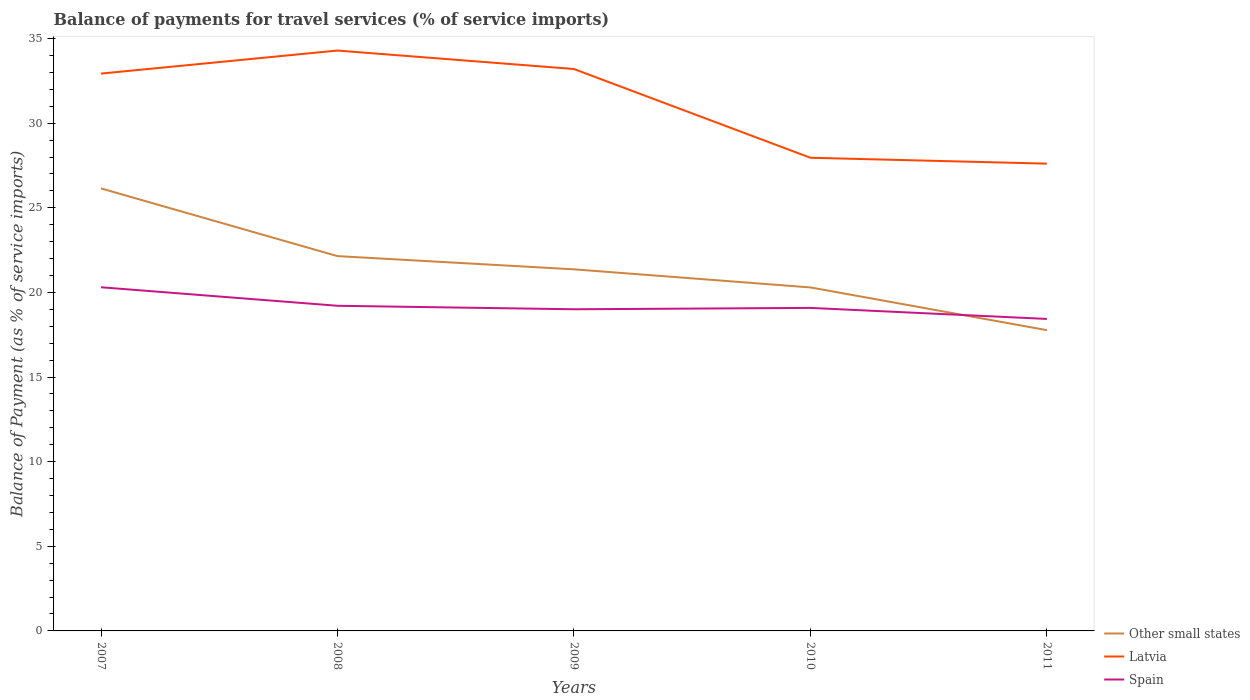Does the line corresponding to Latvia intersect with the line corresponding to Other small states?
Provide a short and direct response. No. Across all years, what is the maximum balance of payments for travel services in Latvia?
Keep it short and to the point. 27.61. What is the total balance of payments for travel services in Spain in the graph?
Your response must be concise. 0.21. What is the difference between the highest and the second highest balance of payments for travel services in Spain?
Give a very brief answer. 1.87. How many lines are there?
Give a very brief answer. 3. How many years are there in the graph?
Provide a short and direct response. 5. What is the difference between two consecutive major ticks on the Y-axis?
Keep it short and to the point. 5. Does the graph contain grids?
Your response must be concise. No. Where does the legend appear in the graph?
Your answer should be very brief. Bottom right. How many legend labels are there?
Offer a terse response. 3. What is the title of the graph?
Give a very brief answer. Balance of payments for travel services (% of service imports). Does "Czech Republic" appear as one of the legend labels in the graph?
Provide a succinct answer. No. What is the label or title of the Y-axis?
Provide a succinct answer. Balance of Payment (as % of service imports). What is the Balance of Payment (as % of service imports) in Other small states in 2007?
Ensure brevity in your answer.  26.15. What is the Balance of Payment (as % of service imports) in Latvia in 2007?
Ensure brevity in your answer.  32.93. What is the Balance of Payment (as % of service imports) of Spain in 2007?
Provide a succinct answer. 20.31. What is the Balance of Payment (as % of service imports) in Other small states in 2008?
Your answer should be compact. 22.15. What is the Balance of Payment (as % of service imports) in Latvia in 2008?
Provide a succinct answer. 34.29. What is the Balance of Payment (as % of service imports) of Spain in 2008?
Offer a very short reply. 19.21. What is the Balance of Payment (as % of service imports) in Other small states in 2009?
Your answer should be compact. 21.37. What is the Balance of Payment (as % of service imports) of Latvia in 2009?
Your answer should be compact. 33.2. What is the Balance of Payment (as % of service imports) of Spain in 2009?
Offer a very short reply. 19.01. What is the Balance of Payment (as % of service imports) of Other small states in 2010?
Your answer should be compact. 20.3. What is the Balance of Payment (as % of service imports) of Latvia in 2010?
Offer a very short reply. 27.96. What is the Balance of Payment (as % of service imports) in Spain in 2010?
Give a very brief answer. 19.09. What is the Balance of Payment (as % of service imports) in Other small states in 2011?
Provide a succinct answer. 17.77. What is the Balance of Payment (as % of service imports) of Latvia in 2011?
Provide a succinct answer. 27.61. What is the Balance of Payment (as % of service imports) of Spain in 2011?
Offer a very short reply. 18.44. Across all years, what is the maximum Balance of Payment (as % of service imports) of Other small states?
Offer a very short reply. 26.15. Across all years, what is the maximum Balance of Payment (as % of service imports) in Latvia?
Your answer should be compact. 34.29. Across all years, what is the maximum Balance of Payment (as % of service imports) in Spain?
Provide a short and direct response. 20.31. Across all years, what is the minimum Balance of Payment (as % of service imports) in Other small states?
Your answer should be very brief. 17.77. Across all years, what is the minimum Balance of Payment (as % of service imports) in Latvia?
Provide a short and direct response. 27.61. Across all years, what is the minimum Balance of Payment (as % of service imports) of Spain?
Your answer should be compact. 18.44. What is the total Balance of Payment (as % of service imports) of Other small states in the graph?
Offer a very short reply. 107.73. What is the total Balance of Payment (as % of service imports) of Latvia in the graph?
Give a very brief answer. 156. What is the total Balance of Payment (as % of service imports) of Spain in the graph?
Your response must be concise. 96.05. What is the difference between the Balance of Payment (as % of service imports) of Other small states in 2007 and that in 2008?
Ensure brevity in your answer.  4. What is the difference between the Balance of Payment (as % of service imports) in Latvia in 2007 and that in 2008?
Offer a terse response. -1.36. What is the difference between the Balance of Payment (as % of service imports) in Spain in 2007 and that in 2008?
Offer a very short reply. 1.09. What is the difference between the Balance of Payment (as % of service imports) in Other small states in 2007 and that in 2009?
Offer a very short reply. 4.78. What is the difference between the Balance of Payment (as % of service imports) of Latvia in 2007 and that in 2009?
Provide a succinct answer. -0.27. What is the difference between the Balance of Payment (as % of service imports) of Spain in 2007 and that in 2009?
Keep it short and to the point. 1.3. What is the difference between the Balance of Payment (as % of service imports) in Other small states in 2007 and that in 2010?
Offer a very short reply. 5.85. What is the difference between the Balance of Payment (as % of service imports) in Latvia in 2007 and that in 2010?
Your answer should be very brief. 4.97. What is the difference between the Balance of Payment (as % of service imports) in Spain in 2007 and that in 2010?
Provide a short and direct response. 1.22. What is the difference between the Balance of Payment (as % of service imports) of Other small states in 2007 and that in 2011?
Your answer should be compact. 8.38. What is the difference between the Balance of Payment (as % of service imports) in Latvia in 2007 and that in 2011?
Provide a short and direct response. 5.32. What is the difference between the Balance of Payment (as % of service imports) of Spain in 2007 and that in 2011?
Offer a very short reply. 1.87. What is the difference between the Balance of Payment (as % of service imports) in Other small states in 2008 and that in 2009?
Give a very brief answer. 0.78. What is the difference between the Balance of Payment (as % of service imports) in Latvia in 2008 and that in 2009?
Give a very brief answer. 1.09. What is the difference between the Balance of Payment (as % of service imports) in Spain in 2008 and that in 2009?
Your answer should be compact. 0.21. What is the difference between the Balance of Payment (as % of service imports) in Other small states in 2008 and that in 2010?
Offer a terse response. 1.85. What is the difference between the Balance of Payment (as % of service imports) of Latvia in 2008 and that in 2010?
Offer a terse response. 6.33. What is the difference between the Balance of Payment (as % of service imports) of Spain in 2008 and that in 2010?
Provide a succinct answer. 0.13. What is the difference between the Balance of Payment (as % of service imports) in Other small states in 2008 and that in 2011?
Your answer should be compact. 4.38. What is the difference between the Balance of Payment (as % of service imports) in Latvia in 2008 and that in 2011?
Ensure brevity in your answer.  6.68. What is the difference between the Balance of Payment (as % of service imports) in Spain in 2008 and that in 2011?
Provide a succinct answer. 0.78. What is the difference between the Balance of Payment (as % of service imports) of Other small states in 2009 and that in 2010?
Ensure brevity in your answer.  1.07. What is the difference between the Balance of Payment (as % of service imports) in Latvia in 2009 and that in 2010?
Give a very brief answer. 5.24. What is the difference between the Balance of Payment (as % of service imports) of Spain in 2009 and that in 2010?
Ensure brevity in your answer.  -0.08. What is the difference between the Balance of Payment (as % of service imports) of Other small states in 2009 and that in 2011?
Your answer should be very brief. 3.59. What is the difference between the Balance of Payment (as % of service imports) in Latvia in 2009 and that in 2011?
Keep it short and to the point. 5.59. What is the difference between the Balance of Payment (as % of service imports) in Spain in 2009 and that in 2011?
Ensure brevity in your answer.  0.57. What is the difference between the Balance of Payment (as % of service imports) of Other small states in 2010 and that in 2011?
Ensure brevity in your answer.  2.53. What is the difference between the Balance of Payment (as % of service imports) of Latvia in 2010 and that in 2011?
Give a very brief answer. 0.35. What is the difference between the Balance of Payment (as % of service imports) of Spain in 2010 and that in 2011?
Keep it short and to the point. 0.65. What is the difference between the Balance of Payment (as % of service imports) of Other small states in 2007 and the Balance of Payment (as % of service imports) of Latvia in 2008?
Your answer should be compact. -8.14. What is the difference between the Balance of Payment (as % of service imports) of Other small states in 2007 and the Balance of Payment (as % of service imports) of Spain in 2008?
Give a very brief answer. 6.94. What is the difference between the Balance of Payment (as % of service imports) of Latvia in 2007 and the Balance of Payment (as % of service imports) of Spain in 2008?
Your answer should be compact. 13.72. What is the difference between the Balance of Payment (as % of service imports) in Other small states in 2007 and the Balance of Payment (as % of service imports) in Latvia in 2009?
Your response must be concise. -7.06. What is the difference between the Balance of Payment (as % of service imports) in Other small states in 2007 and the Balance of Payment (as % of service imports) in Spain in 2009?
Your answer should be very brief. 7.14. What is the difference between the Balance of Payment (as % of service imports) of Latvia in 2007 and the Balance of Payment (as % of service imports) of Spain in 2009?
Provide a short and direct response. 13.93. What is the difference between the Balance of Payment (as % of service imports) of Other small states in 2007 and the Balance of Payment (as % of service imports) of Latvia in 2010?
Ensure brevity in your answer.  -1.81. What is the difference between the Balance of Payment (as % of service imports) in Other small states in 2007 and the Balance of Payment (as % of service imports) in Spain in 2010?
Make the answer very short. 7.06. What is the difference between the Balance of Payment (as % of service imports) in Latvia in 2007 and the Balance of Payment (as % of service imports) in Spain in 2010?
Keep it short and to the point. 13.84. What is the difference between the Balance of Payment (as % of service imports) in Other small states in 2007 and the Balance of Payment (as % of service imports) in Latvia in 2011?
Give a very brief answer. -1.46. What is the difference between the Balance of Payment (as % of service imports) in Other small states in 2007 and the Balance of Payment (as % of service imports) in Spain in 2011?
Keep it short and to the point. 7.71. What is the difference between the Balance of Payment (as % of service imports) in Latvia in 2007 and the Balance of Payment (as % of service imports) in Spain in 2011?
Keep it short and to the point. 14.5. What is the difference between the Balance of Payment (as % of service imports) in Other small states in 2008 and the Balance of Payment (as % of service imports) in Latvia in 2009?
Ensure brevity in your answer.  -11.06. What is the difference between the Balance of Payment (as % of service imports) in Other small states in 2008 and the Balance of Payment (as % of service imports) in Spain in 2009?
Offer a terse response. 3.14. What is the difference between the Balance of Payment (as % of service imports) of Latvia in 2008 and the Balance of Payment (as % of service imports) of Spain in 2009?
Your response must be concise. 15.29. What is the difference between the Balance of Payment (as % of service imports) of Other small states in 2008 and the Balance of Payment (as % of service imports) of Latvia in 2010?
Offer a very short reply. -5.81. What is the difference between the Balance of Payment (as % of service imports) in Other small states in 2008 and the Balance of Payment (as % of service imports) in Spain in 2010?
Your answer should be compact. 3.06. What is the difference between the Balance of Payment (as % of service imports) of Latvia in 2008 and the Balance of Payment (as % of service imports) of Spain in 2010?
Give a very brief answer. 15.21. What is the difference between the Balance of Payment (as % of service imports) in Other small states in 2008 and the Balance of Payment (as % of service imports) in Latvia in 2011?
Offer a very short reply. -5.46. What is the difference between the Balance of Payment (as % of service imports) in Other small states in 2008 and the Balance of Payment (as % of service imports) in Spain in 2011?
Your answer should be very brief. 3.71. What is the difference between the Balance of Payment (as % of service imports) in Latvia in 2008 and the Balance of Payment (as % of service imports) in Spain in 2011?
Provide a succinct answer. 15.86. What is the difference between the Balance of Payment (as % of service imports) of Other small states in 2009 and the Balance of Payment (as % of service imports) of Latvia in 2010?
Your answer should be very brief. -6.59. What is the difference between the Balance of Payment (as % of service imports) in Other small states in 2009 and the Balance of Payment (as % of service imports) in Spain in 2010?
Make the answer very short. 2.28. What is the difference between the Balance of Payment (as % of service imports) of Latvia in 2009 and the Balance of Payment (as % of service imports) of Spain in 2010?
Your response must be concise. 14.12. What is the difference between the Balance of Payment (as % of service imports) of Other small states in 2009 and the Balance of Payment (as % of service imports) of Latvia in 2011?
Your response must be concise. -6.25. What is the difference between the Balance of Payment (as % of service imports) of Other small states in 2009 and the Balance of Payment (as % of service imports) of Spain in 2011?
Offer a terse response. 2.93. What is the difference between the Balance of Payment (as % of service imports) in Latvia in 2009 and the Balance of Payment (as % of service imports) in Spain in 2011?
Provide a short and direct response. 14.77. What is the difference between the Balance of Payment (as % of service imports) in Other small states in 2010 and the Balance of Payment (as % of service imports) in Latvia in 2011?
Offer a very short reply. -7.31. What is the difference between the Balance of Payment (as % of service imports) of Other small states in 2010 and the Balance of Payment (as % of service imports) of Spain in 2011?
Your response must be concise. 1.86. What is the difference between the Balance of Payment (as % of service imports) in Latvia in 2010 and the Balance of Payment (as % of service imports) in Spain in 2011?
Your response must be concise. 9.52. What is the average Balance of Payment (as % of service imports) in Other small states per year?
Offer a terse response. 21.55. What is the average Balance of Payment (as % of service imports) in Latvia per year?
Offer a terse response. 31.2. What is the average Balance of Payment (as % of service imports) of Spain per year?
Offer a terse response. 19.21. In the year 2007, what is the difference between the Balance of Payment (as % of service imports) in Other small states and Balance of Payment (as % of service imports) in Latvia?
Your answer should be very brief. -6.78. In the year 2007, what is the difference between the Balance of Payment (as % of service imports) of Other small states and Balance of Payment (as % of service imports) of Spain?
Offer a very short reply. 5.84. In the year 2007, what is the difference between the Balance of Payment (as % of service imports) in Latvia and Balance of Payment (as % of service imports) in Spain?
Keep it short and to the point. 12.62. In the year 2008, what is the difference between the Balance of Payment (as % of service imports) in Other small states and Balance of Payment (as % of service imports) in Latvia?
Your answer should be very brief. -12.15. In the year 2008, what is the difference between the Balance of Payment (as % of service imports) in Other small states and Balance of Payment (as % of service imports) in Spain?
Ensure brevity in your answer.  2.93. In the year 2008, what is the difference between the Balance of Payment (as % of service imports) in Latvia and Balance of Payment (as % of service imports) in Spain?
Your answer should be compact. 15.08. In the year 2009, what is the difference between the Balance of Payment (as % of service imports) of Other small states and Balance of Payment (as % of service imports) of Latvia?
Your answer should be very brief. -11.84. In the year 2009, what is the difference between the Balance of Payment (as % of service imports) in Other small states and Balance of Payment (as % of service imports) in Spain?
Offer a very short reply. 2.36. In the year 2009, what is the difference between the Balance of Payment (as % of service imports) of Latvia and Balance of Payment (as % of service imports) of Spain?
Offer a terse response. 14.2. In the year 2010, what is the difference between the Balance of Payment (as % of service imports) in Other small states and Balance of Payment (as % of service imports) in Latvia?
Make the answer very short. -7.66. In the year 2010, what is the difference between the Balance of Payment (as % of service imports) in Other small states and Balance of Payment (as % of service imports) in Spain?
Offer a very short reply. 1.21. In the year 2010, what is the difference between the Balance of Payment (as % of service imports) of Latvia and Balance of Payment (as % of service imports) of Spain?
Make the answer very short. 8.87. In the year 2011, what is the difference between the Balance of Payment (as % of service imports) of Other small states and Balance of Payment (as % of service imports) of Latvia?
Provide a short and direct response. -9.84. In the year 2011, what is the difference between the Balance of Payment (as % of service imports) in Other small states and Balance of Payment (as % of service imports) in Spain?
Provide a succinct answer. -0.66. In the year 2011, what is the difference between the Balance of Payment (as % of service imports) in Latvia and Balance of Payment (as % of service imports) in Spain?
Ensure brevity in your answer.  9.18. What is the ratio of the Balance of Payment (as % of service imports) of Other small states in 2007 to that in 2008?
Your response must be concise. 1.18. What is the ratio of the Balance of Payment (as % of service imports) in Latvia in 2007 to that in 2008?
Offer a terse response. 0.96. What is the ratio of the Balance of Payment (as % of service imports) in Spain in 2007 to that in 2008?
Provide a succinct answer. 1.06. What is the ratio of the Balance of Payment (as % of service imports) of Other small states in 2007 to that in 2009?
Provide a succinct answer. 1.22. What is the ratio of the Balance of Payment (as % of service imports) in Latvia in 2007 to that in 2009?
Your response must be concise. 0.99. What is the ratio of the Balance of Payment (as % of service imports) of Spain in 2007 to that in 2009?
Your response must be concise. 1.07. What is the ratio of the Balance of Payment (as % of service imports) of Other small states in 2007 to that in 2010?
Your answer should be very brief. 1.29. What is the ratio of the Balance of Payment (as % of service imports) in Latvia in 2007 to that in 2010?
Ensure brevity in your answer.  1.18. What is the ratio of the Balance of Payment (as % of service imports) of Spain in 2007 to that in 2010?
Give a very brief answer. 1.06. What is the ratio of the Balance of Payment (as % of service imports) of Other small states in 2007 to that in 2011?
Make the answer very short. 1.47. What is the ratio of the Balance of Payment (as % of service imports) in Latvia in 2007 to that in 2011?
Provide a succinct answer. 1.19. What is the ratio of the Balance of Payment (as % of service imports) in Spain in 2007 to that in 2011?
Provide a short and direct response. 1.1. What is the ratio of the Balance of Payment (as % of service imports) in Other small states in 2008 to that in 2009?
Offer a very short reply. 1.04. What is the ratio of the Balance of Payment (as % of service imports) of Latvia in 2008 to that in 2009?
Give a very brief answer. 1.03. What is the ratio of the Balance of Payment (as % of service imports) in Spain in 2008 to that in 2009?
Provide a short and direct response. 1.01. What is the ratio of the Balance of Payment (as % of service imports) of Other small states in 2008 to that in 2010?
Offer a very short reply. 1.09. What is the ratio of the Balance of Payment (as % of service imports) of Latvia in 2008 to that in 2010?
Your answer should be compact. 1.23. What is the ratio of the Balance of Payment (as % of service imports) in Spain in 2008 to that in 2010?
Ensure brevity in your answer.  1.01. What is the ratio of the Balance of Payment (as % of service imports) of Other small states in 2008 to that in 2011?
Give a very brief answer. 1.25. What is the ratio of the Balance of Payment (as % of service imports) of Latvia in 2008 to that in 2011?
Keep it short and to the point. 1.24. What is the ratio of the Balance of Payment (as % of service imports) in Spain in 2008 to that in 2011?
Keep it short and to the point. 1.04. What is the ratio of the Balance of Payment (as % of service imports) in Other small states in 2009 to that in 2010?
Your answer should be compact. 1.05. What is the ratio of the Balance of Payment (as % of service imports) in Latvia in 2009 to that in 2010?
Provide a succinct answer. 1.19. What is the ratio of the Balance of Payment (as % of service imports) in Other small states in 2009 to that in 2011?
Your answer should be very brief. 1.2. What is the ratio of the Balance of Payment (as % of service imports) in Latvia in 2009 to that in 2011?
Your response must be concise. 1.2. What is the ratio of the Balance of Payment (as % of service imports) of Spain in 2009 to that in 2011?
Keep it short and to the point. 1.03. What is the ratio of the Balance of Payment (as % of service imports) of Other small states in 2010 to that in 2011?
Keep it short and to the point. 1.14. What is the ratio of the Balance of Payment (as % of service imports) of Latvia in 2010 to that in 2011?
Your answer should be very brief. 1.01. What is the ratio of the Balance of Payment (as % of service imports) in Spain in 2010 to that in 2011?
Your response must be concise. 1.04. What is the difference between the highest and the second highest Balance of Payment (as % of service imports) in Other small states?
Ensure brevity in your answer.  4. What is the difference between the highest and the second highest Balance of Payment (as % of service imports) of Latvia?
Your response must be concise. 1.09. What is the difference between the highest and the second highest Balance of Payment (as % of service imports) in Spain?
Your response must be concise. 1.09. What is the difference between the highest and the lowest Balance of Payment (as % of service imports) of Other small states?
Your response must be concise. 8.38. What is the difference between the highest and the lowest Balance of Payment (as % of service imports) in Latvia?
Keep it short and to the point. 6.68. What is the difference between the highest and the lowest Balance of Payment (as % of service imports) in Spain?
Ensure brevity in your answer.  1.87. 